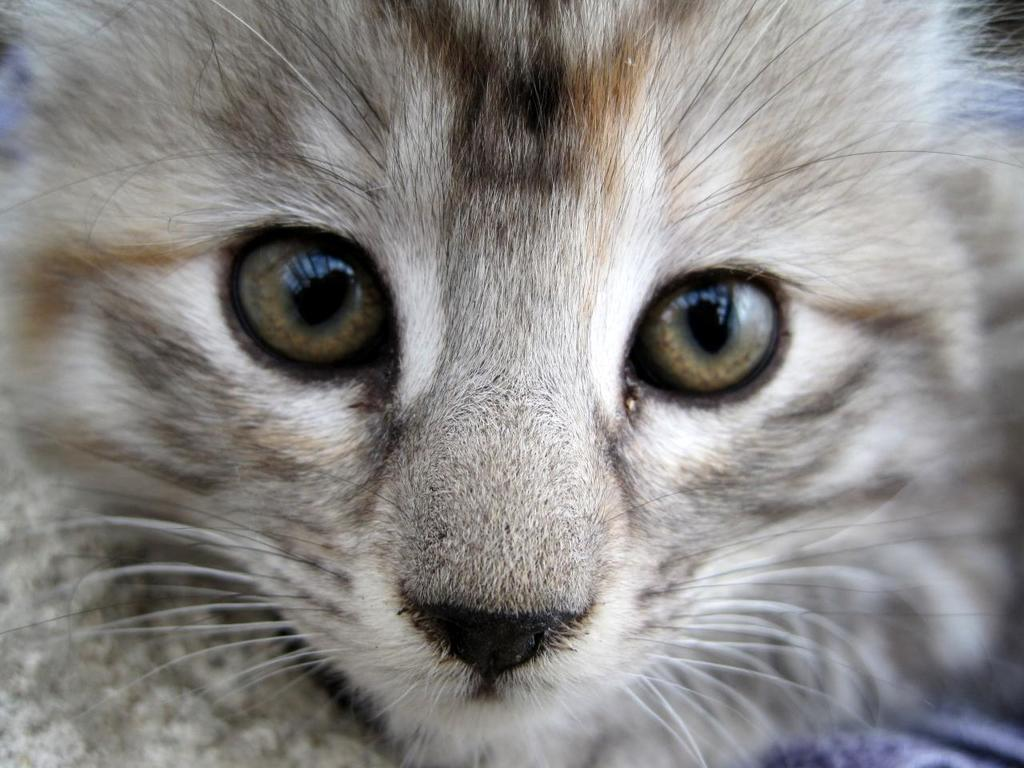What is the main subject of the image? There is a cat face in the center of the image. How many cherries are hanging from the cat's whiskers in the image? There are no cherries present in the image, and the cat's whiskers are not mentioned. 